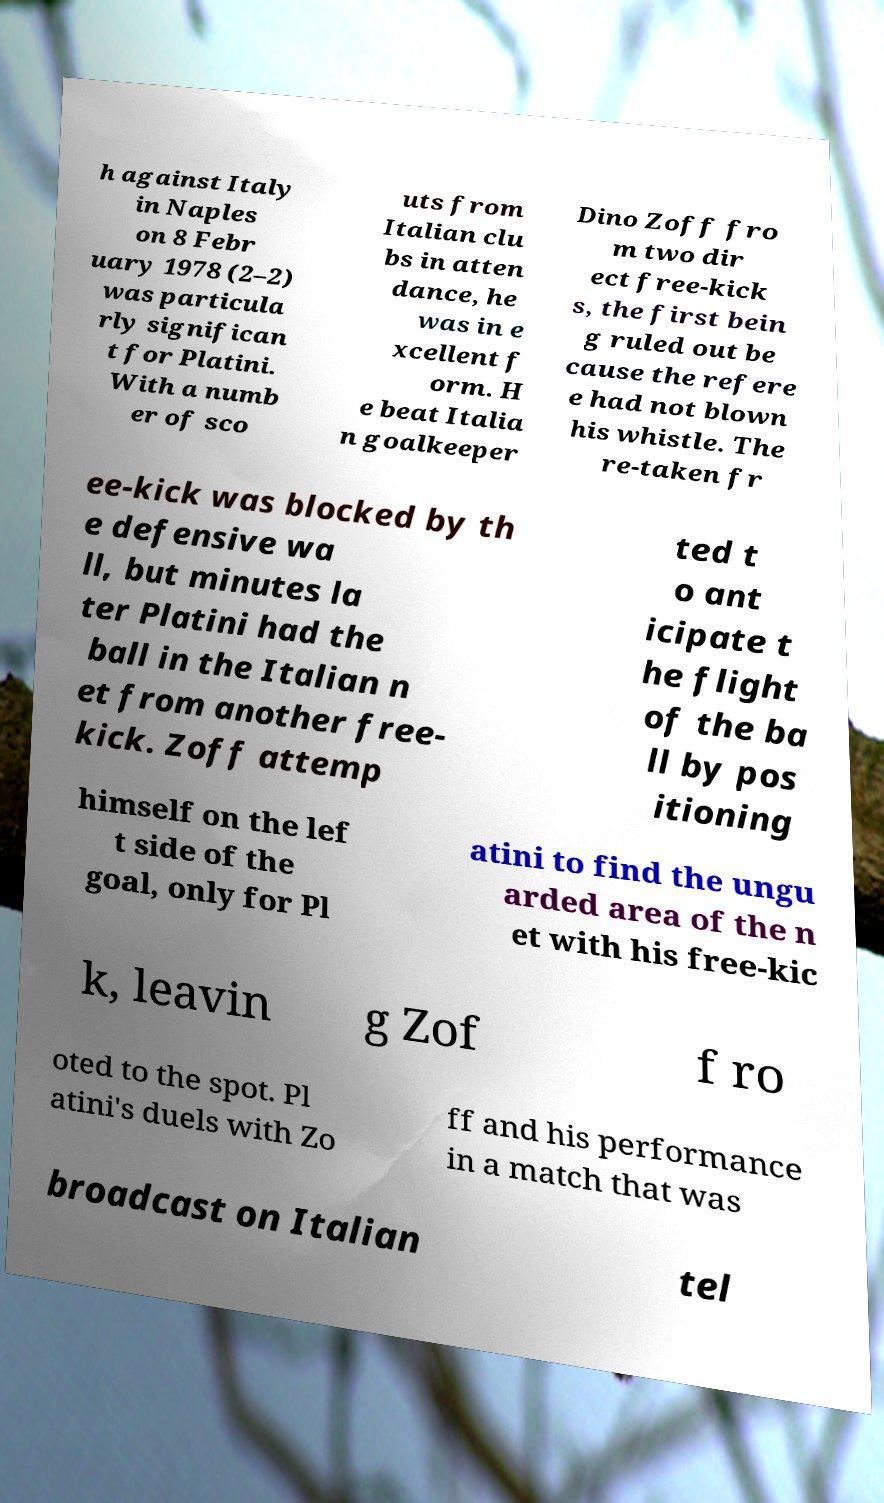Please read and relay the text visible in this image. What does it say? h against Italy in Naples on 8 Febr uary 1978 (2–2) was particula rly significan t for Platini. With a numb er of sco uts from Italian clu bs in atten dance, he was in e xcellent f orm. H e beat Italia n goalkeeper Dino Zoff fro m two dir ect free-kick s, the first bein g ruled out be cause the refere e had not blown his whistle. The re-taken fr ee-kick was blocked by th e defensive wa ll, but minutes la ter Platini had the ball in the Italian n et from another free- kick. Zoff attemp ted t o ant icipate t he flight of the ba ll by pos itioning himself on the lef t side of the goal, only for Pl atini to find the ungu arded area of the n et with his free-kic k, leavin g Zof f ro oted to the spot. Pl atini's duels with Zo ff and his performance in a match that was broadcast on Italian tel 